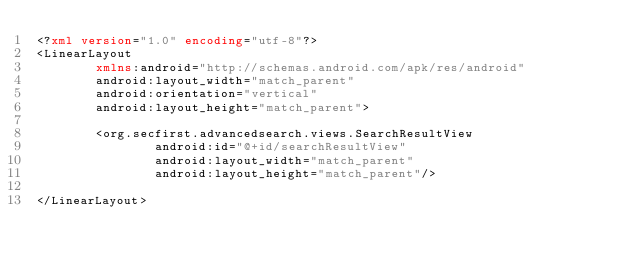<code> <loc_0><loc_0><loc_500><loc_500><_XML_><?xml version="1.0" encoding="utf-8"?>
<LinearLayout
        xmlns:android="http://schemas.android.com/apk/res/android"
        android:layout_width="match_parent"
        android:orientation="vertical"
        android:layout_height="match_parent">

        <org.secfirst.advancedsearch.views.SearchResultView
                android:id="@+id/searchResultView"
                android:layout_width="match_parent"
                android:layout_height="match_parent"/>

</LinearLayout></code> 